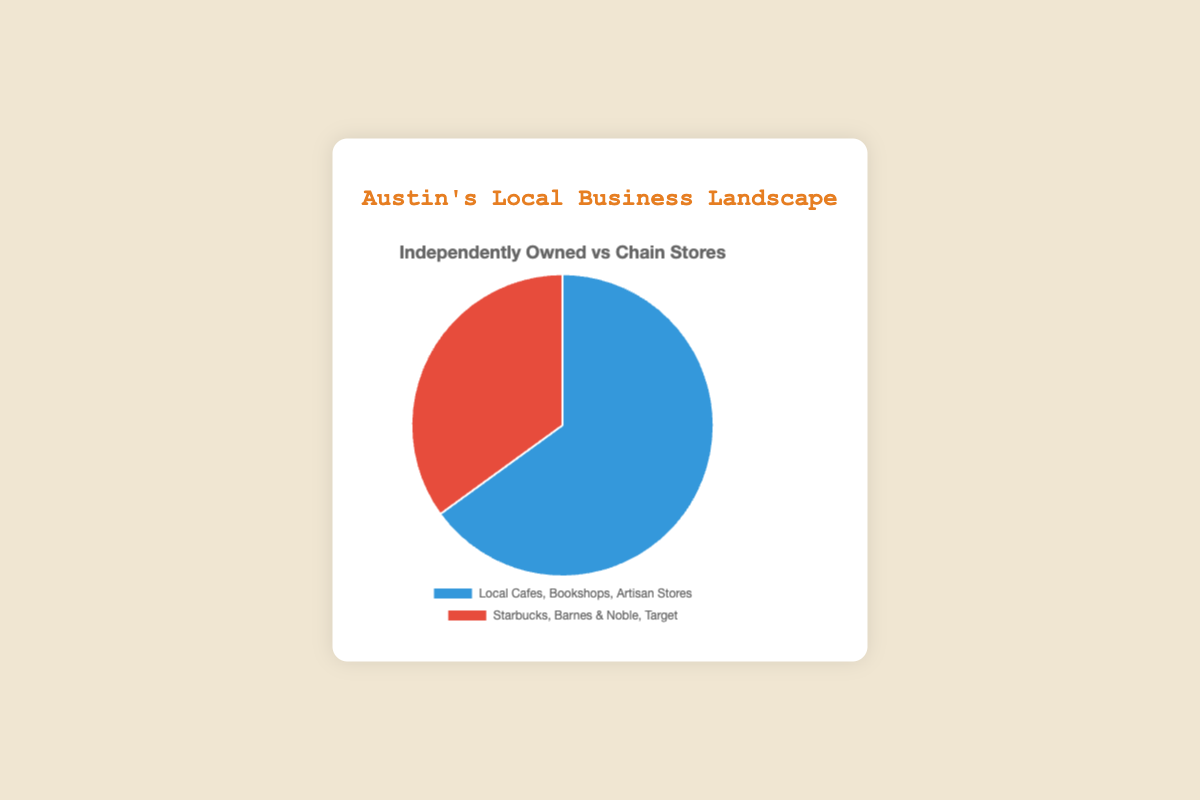What are the two categories of businesses represented in the pie chart? The pie chart displays two categories of businesses: "Local Cafes, Bookshops, Artisan Stores" represented by independently owned businesses, and "Starbucks, Barnes & Noble, Target" represented by chain stores.
Answer: Local Cafes, Bookshops, Artisan Stores and Starbucks, Barnes & Noble, Target Which category has a higher proportion of businesses in Austin? The category with the higher proportion can be identified by the larger segment in the pie chart. In this case, the independently owned businesses have a greater proportion than chain stores.
Answer: Independently owned businesses What proportion of local businesses in Austin are chain stores? The chart shows that chain stores make up the smaller segment, which corresponds to 35% of local businesses in Austin.
Answer: 35% How much greater is the proportion of independently owned businesses compared to chain stores? The difference in proportions is calculated by subtracting the chain store proportion from the independently owned proportion: 65% - 35% = 30%.
Answer: 30% If you combine both proportions, what percentage do you get? Add the two proportions together to find the total percentage: 65% + 35% = 100%.
Answer: 100% What color represents independently owned businesses in the pie chart? The visual attribute of color can be identified; independently owned businesses are represented by blue in the pie chart.
Answer: Blue By how much does the proportion of independently owned businesses exceed half of the total proportion? Calculate how much independently owned businesses exceed 50% by subtracting 50% from 65%: 65% - 50% = 15%.
Answer: 15% Which proportion is represented by the color red in the pie chart? By observing the color representation, the chain stores are displayed in red in the pie chart.
Answer: Chain stores If Austin's local business landscape shifted to have proportions of 50-50, how much reduction would be needed from independently owned businesses' current proportion? To achieve a 50-50 proportion, the current proportion of independently owned businesses would need to be reduced by 15% (65% - 50%).
Answer: 15% What is the combined proportion of businesses if the independently owned category was double the chain stores' proportion? Doubling the chain store proportion gives 70% (35% * 2). Adding this to the 35% proportion of chain stores gives a total of 105%.
Answer: 105% 